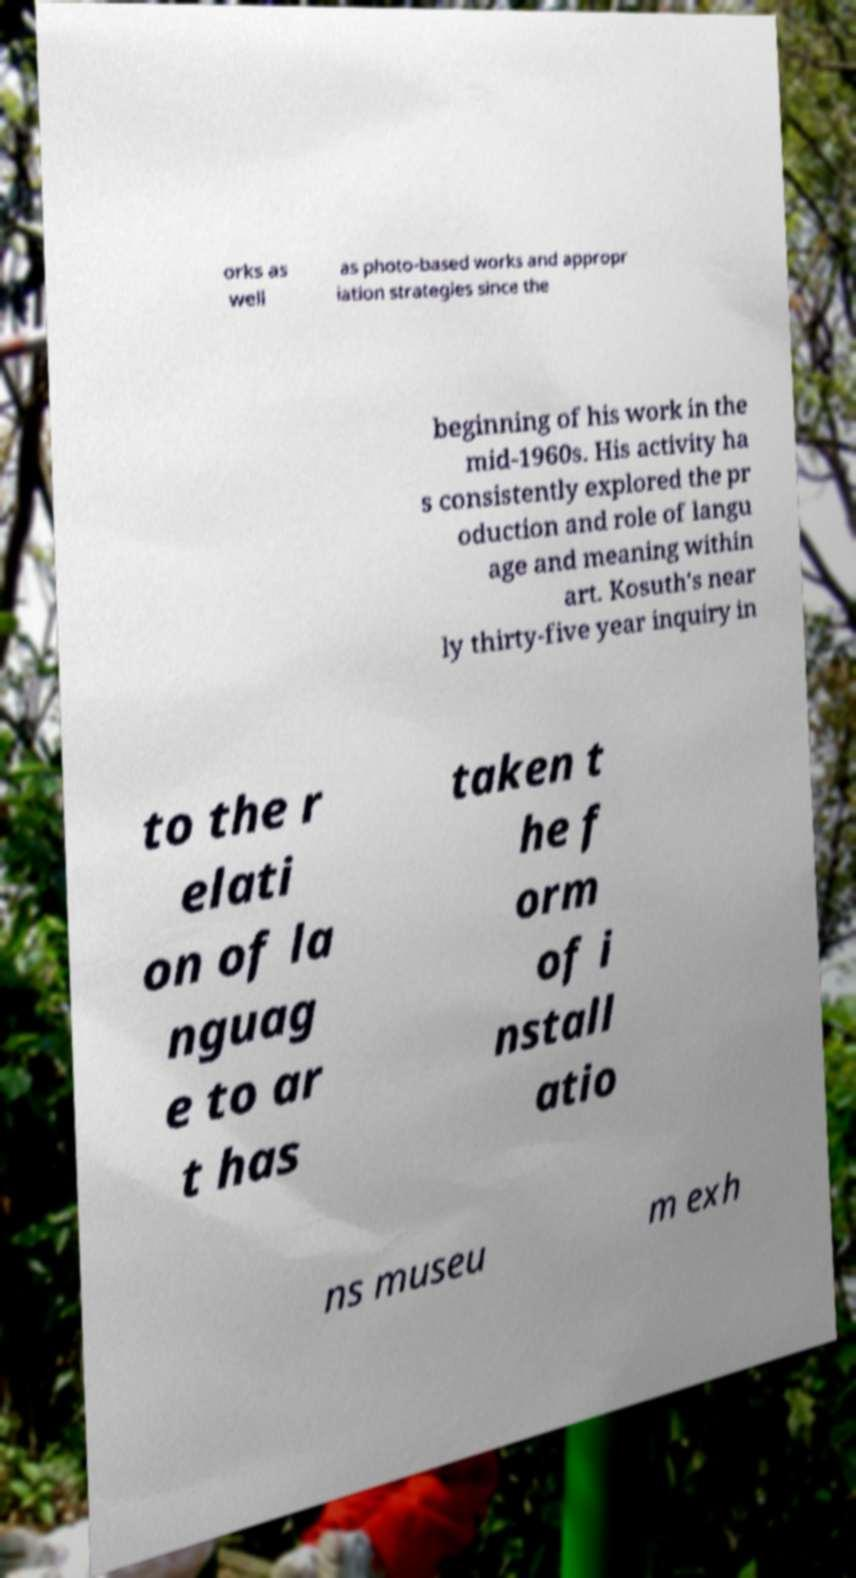Can you read and provide the text displayed in the image?This photo seems to have some interesting text. Can you extract and type it out for me? orks as well as photo-based works and appropr iation strategies since the beginning of his work in the mid-1960s. His activity ha s consistently explored the pr oduction and role of langu age and meaning within art. Kosuth's near ly thirty-five year inquiry in to the r elati on of la nguag e to ar t has taken t he f orm of i nstall atio ns museu m exh 